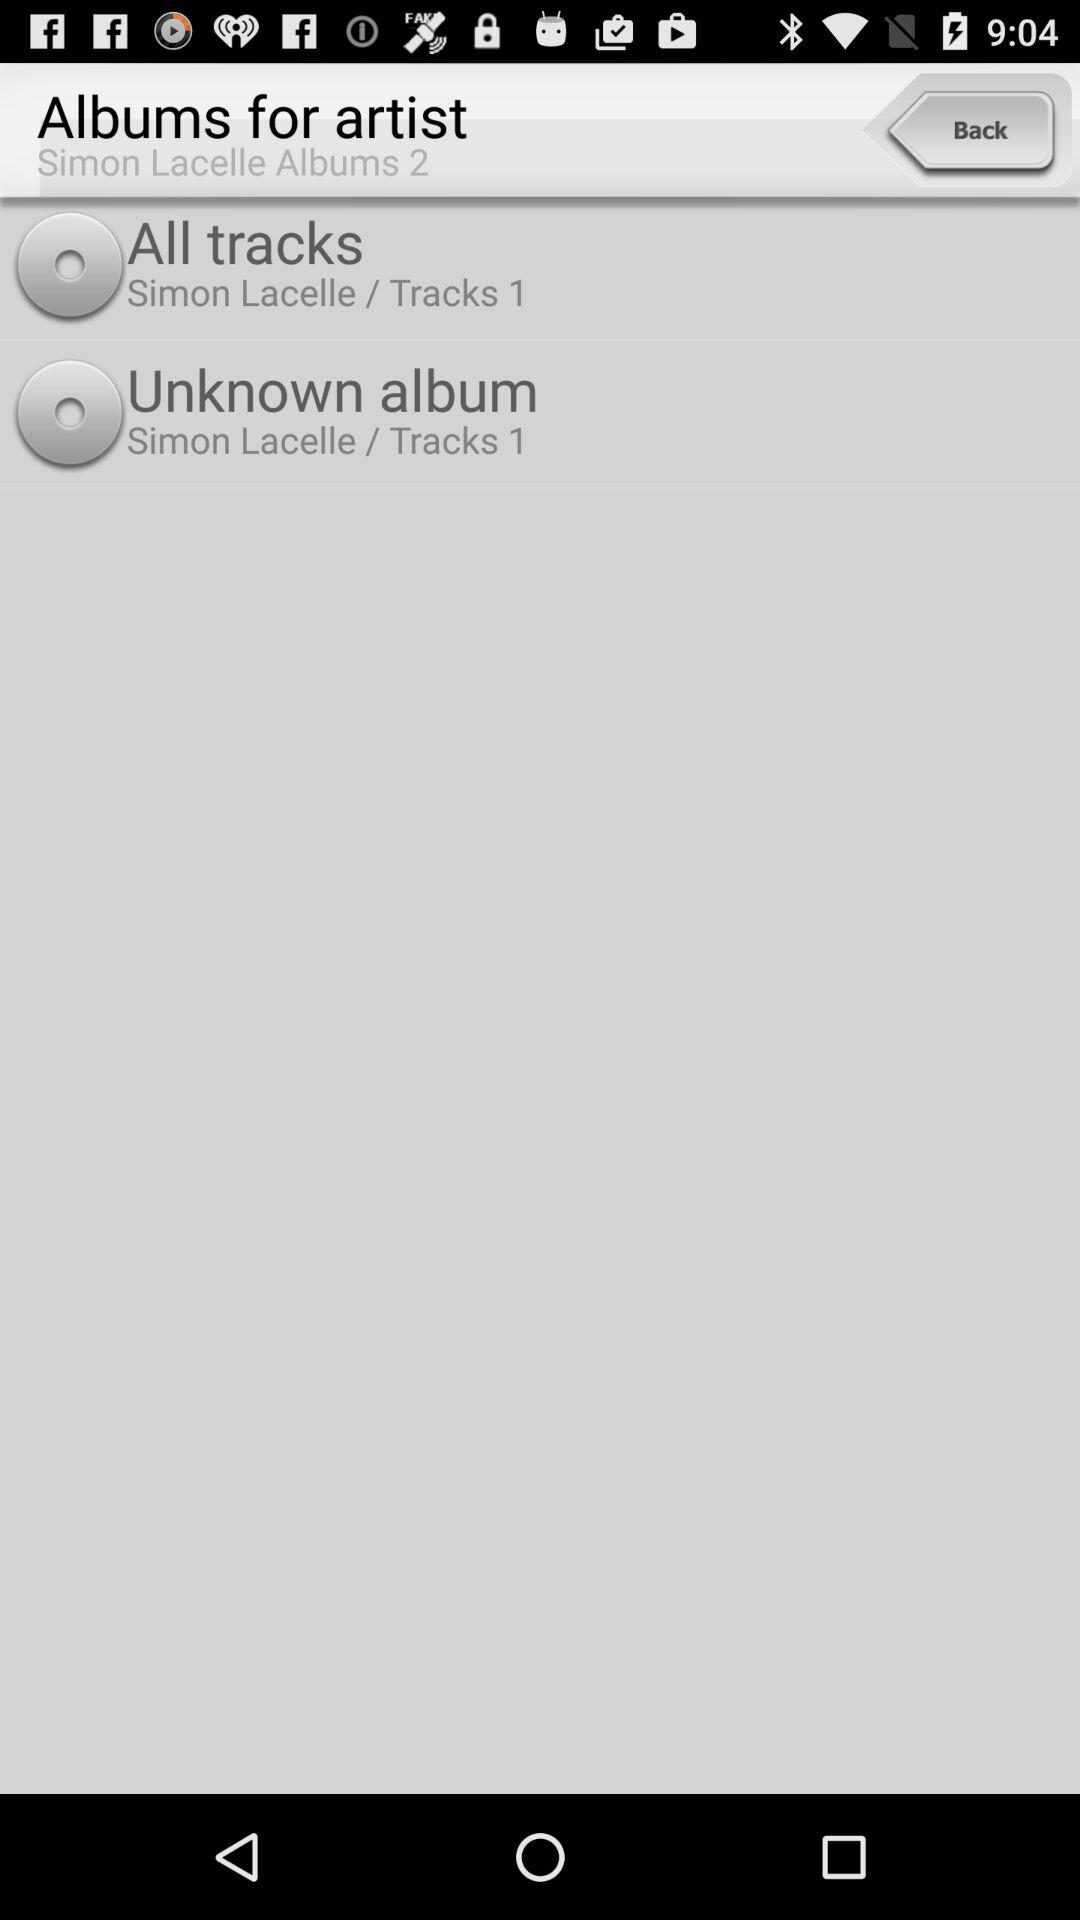How many albums are available for Simon Lacelle?
Answer the question using a single word or phrase. 2 